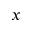Convert formula to latex. <formula><loc_0><loc_0><loc_500><loc_500>x</formula> 